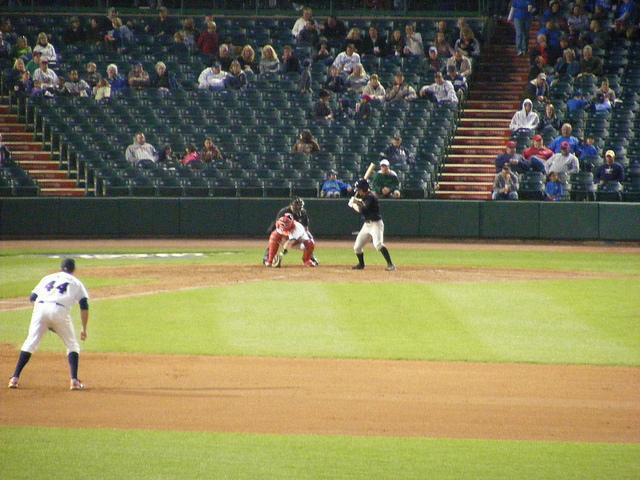How many people can be seen?
Give a very brief answer. 2. How many train tracks are visible?
Give a very brief answer. 0. 